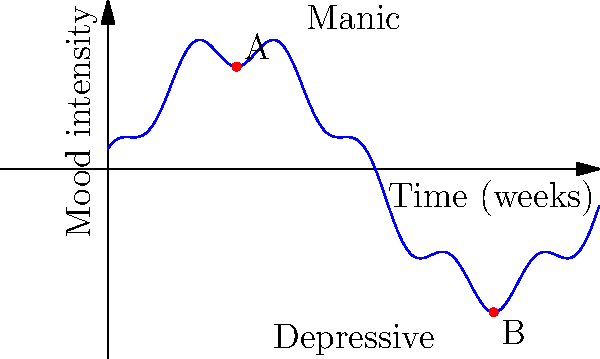The graph represents the mood fluctuations of a patient with bipolar disorder over a 12-week period. Point A represents a manic episode, and point B represents a depressive episode. If the x-axis represents time in weeks and the y-axis represents mood intensity, what is the approximate time difference (in weeks) between the manic episode (A) and the depressive episode (B)? To find the time difference between the manic episode (A) and the depressive episode (B), we need to:

1. Identify the x-coordinates (time values) of points A and B:
   Point A: $x_A \approx 3.14$ weeks
   Point B: $x_B \approx 9.42$ weeks

2. Calculate the difference between these x-values:
   $\Delta x = x_B - x_A$
   $\Delta x = 9.42 - 3.14$
   $\Delta x \approx 6.28$ weeks

3. Round to the nearest week for a more practical clinical interpretation:
   $6.28$ weeks ≈ $6$ weeks

Therefore, the approximate time difference between the manic episode (A) and the depressive episode (B) is 6 weeks.
Answer: 6 weeks 